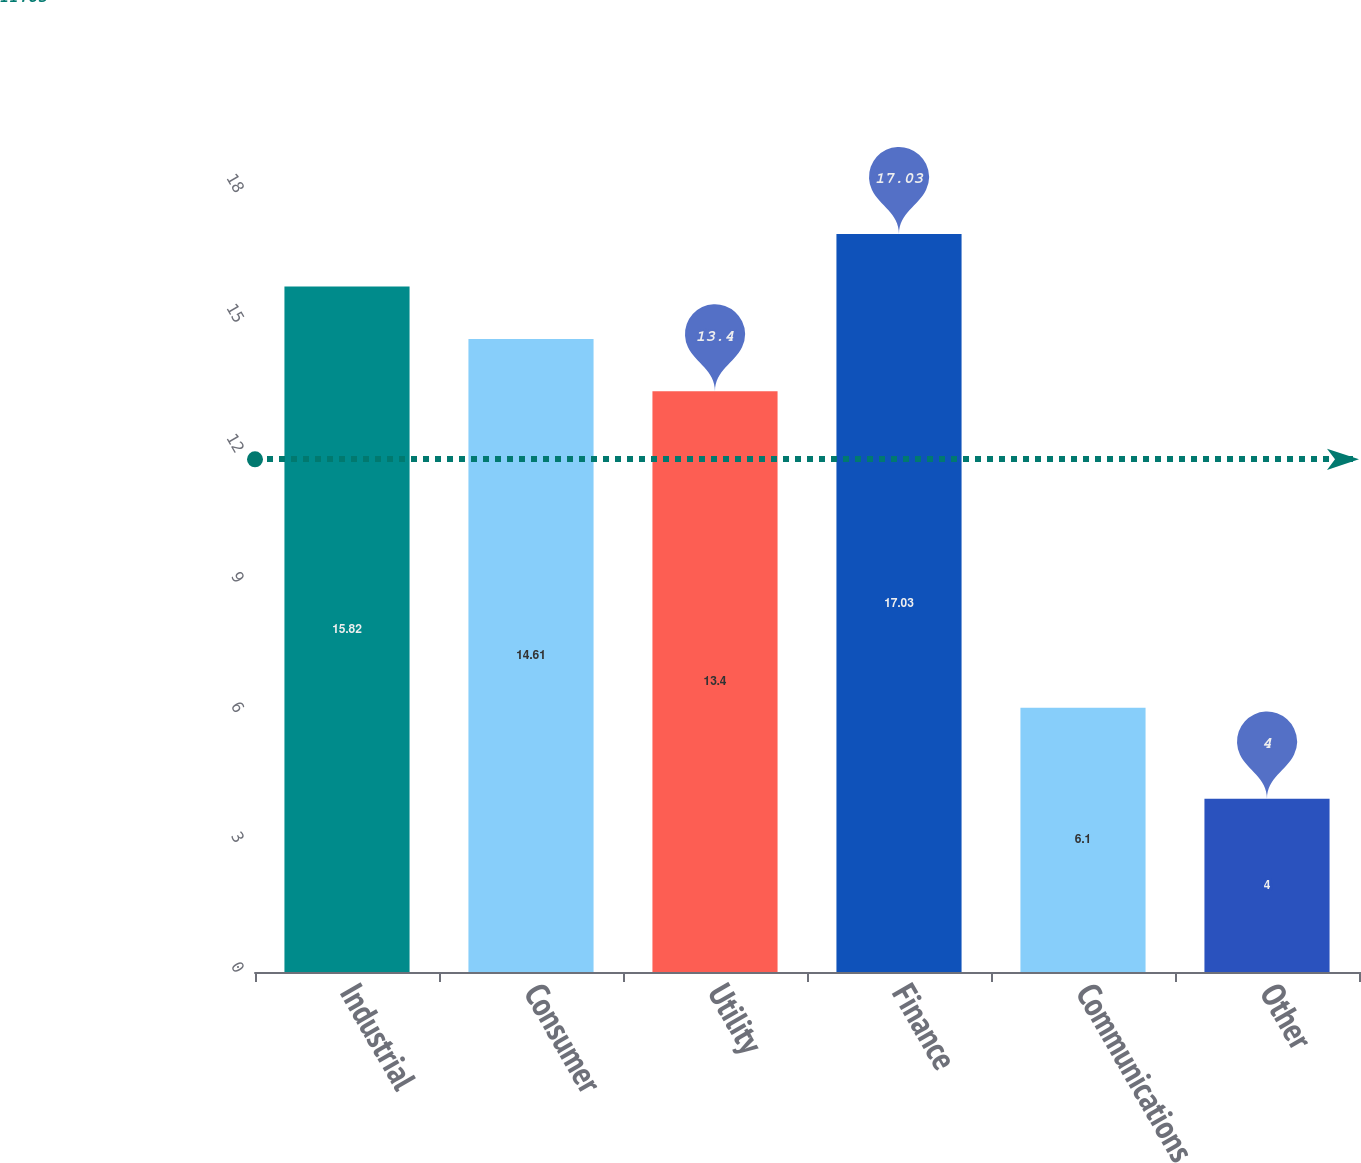Convert chart. <chart><loc_0><loc_0><loc_500><loc_500><bar_chart><fcel>Industrial<fcel>Consumer<fcel>Utility<fcel>Finance<fcel>Communications<fcel>Other<nl><fcel>15.82<fcel>14.61<fcel>13.4<fcel>17.03<fcel>6.1<fcel>4<nl></chart> 